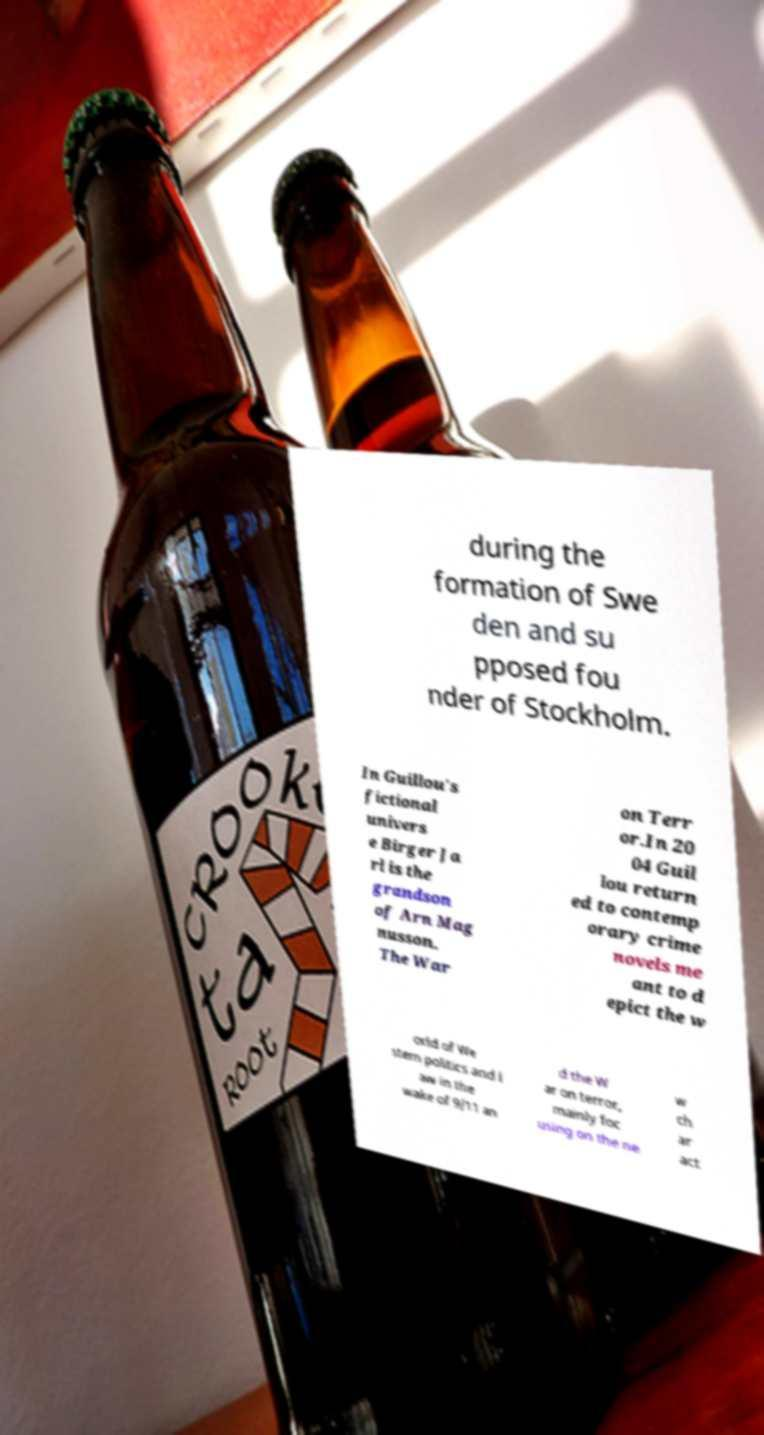There's text embedded in this image that I need extracted. Can you transcribe it verbatim? during the formation of Swe den and su pposed fou nder of Stockholm. In Guillou's fictional univers e Birger Ja rl is the grandson of Arn Mag nusson. The War on Terr or.In 20 04 Guil lou return ed to contemp orary crime novels me ant to d epict the w orld of We stern politics and l aw in the wake of 9/11 an d the W ar on terror, mainly foc using on the ne w ch ar act 